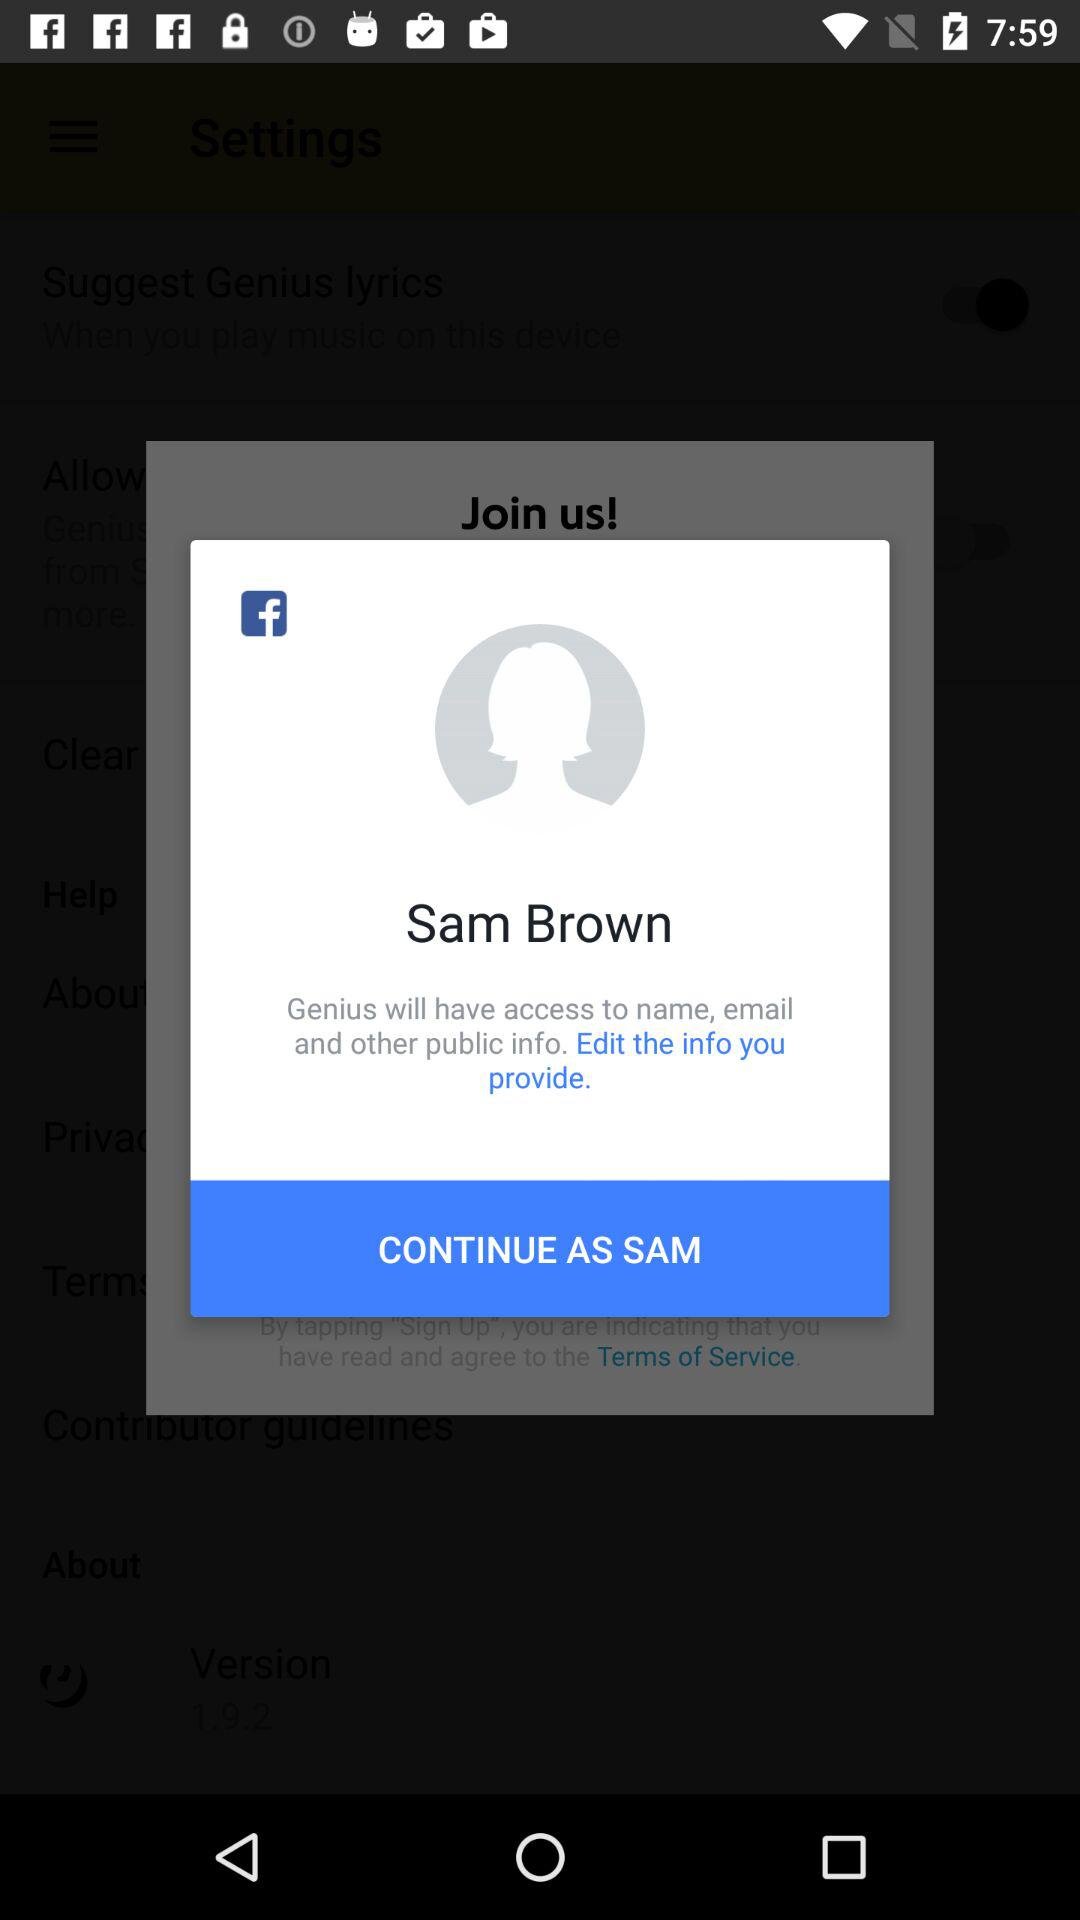What is the name? The name is Sam Brown. 